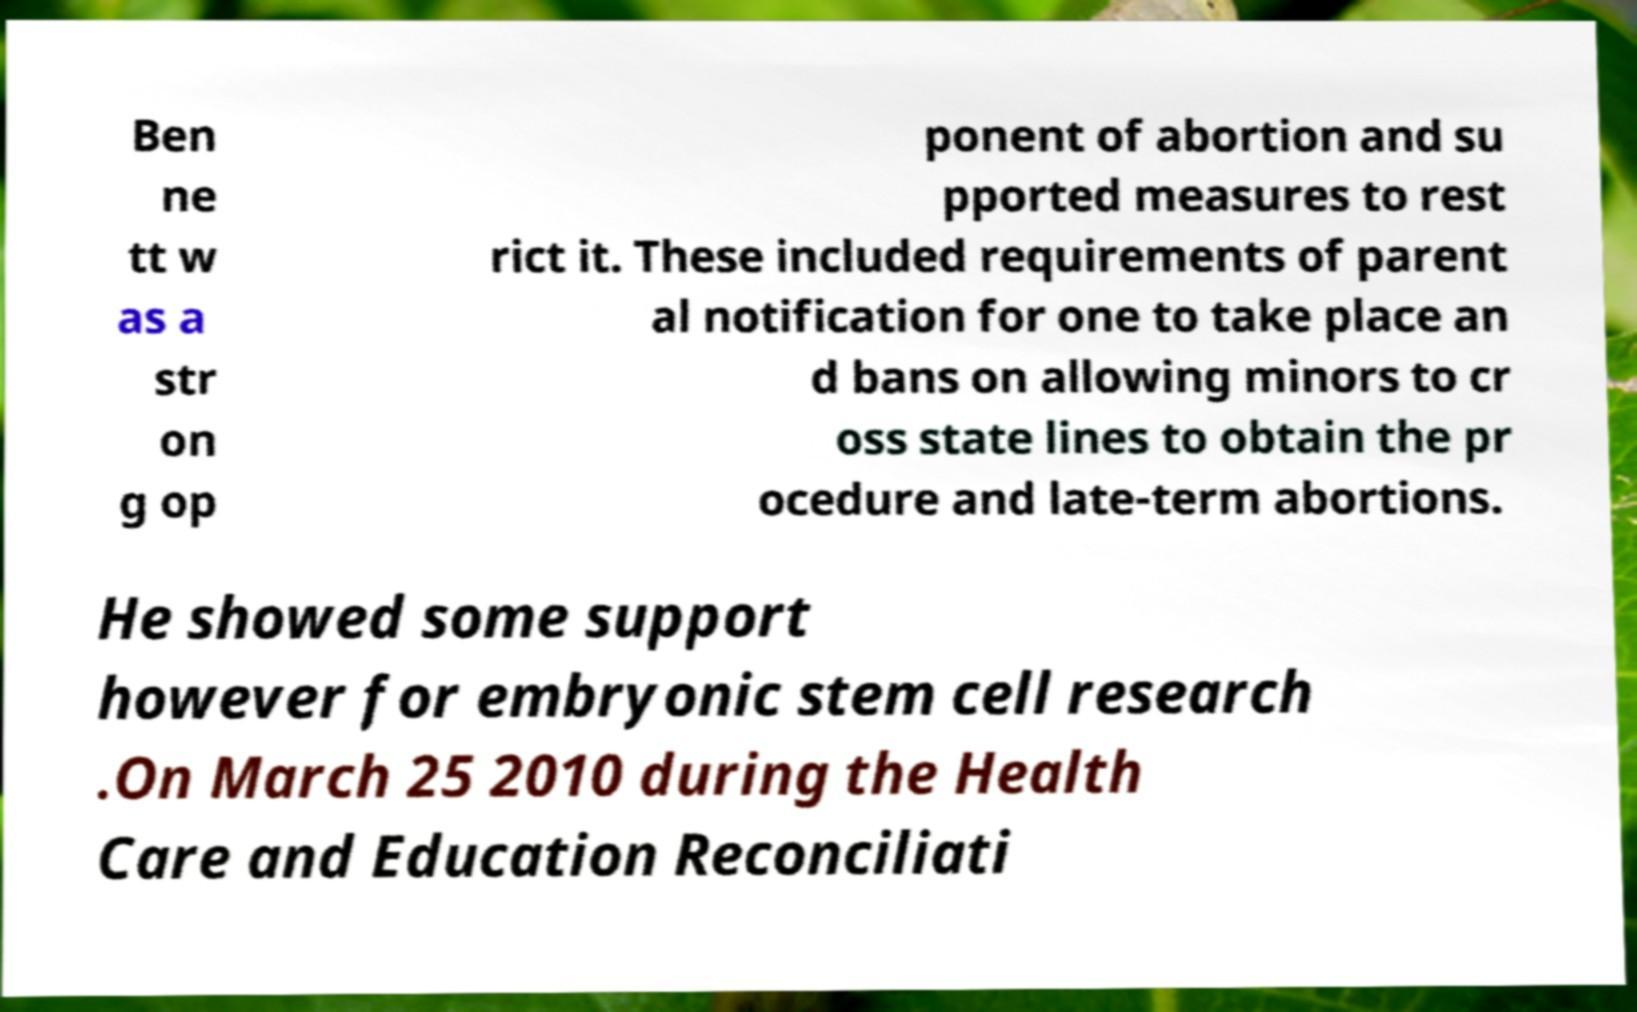Could you extract and type out the text from this image? Ben ne tt w as a str on g op ponent of abortion and su pported measures to rest rict it. These included requirements of parent al notification for one to take place an d bans on allowing minors to cr oss state lines to obtain the pr ocedure and late-term abortions. He showed some support however for embryonic stem cell research .On March 25 2010 during the Health Care and Education Reconciliati 